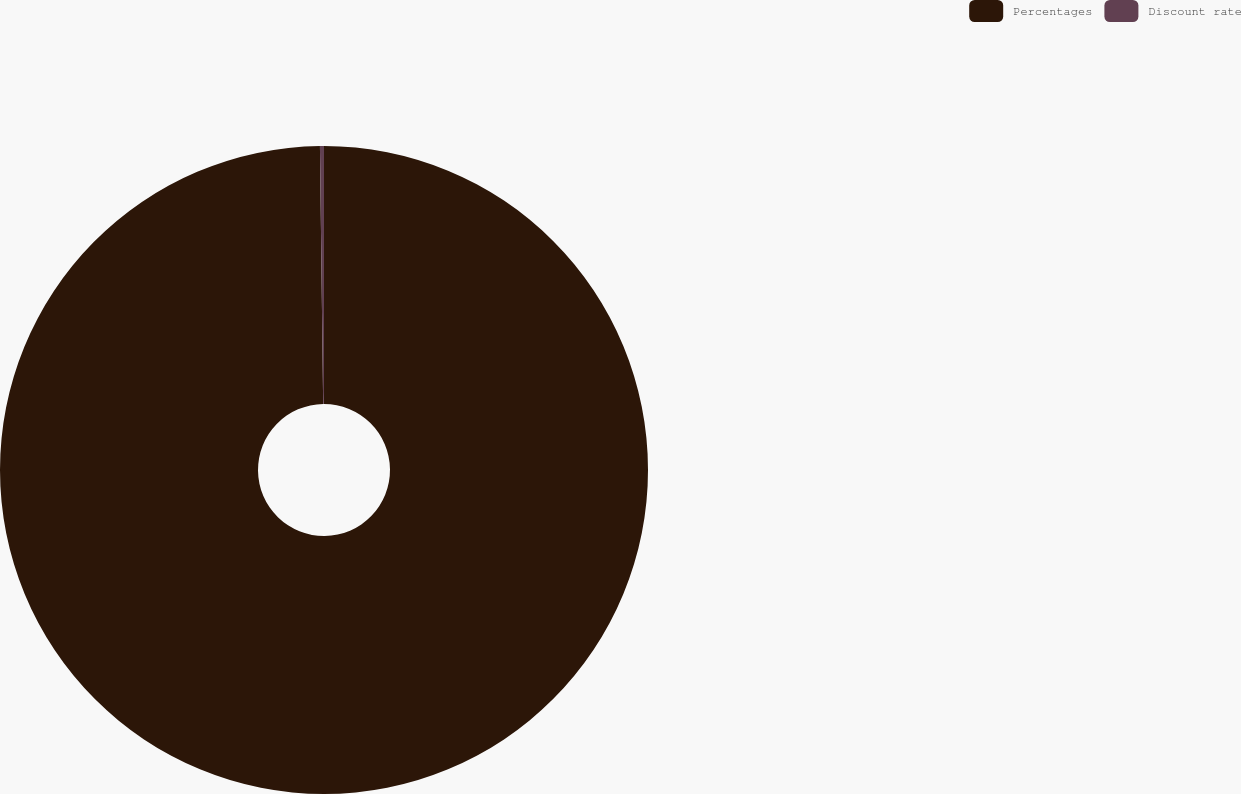Convert chart. <chart><loc_0><loc_0><loc_500><loc_500><pie_chart><fcel>Percentages<fcel>Discount rate<nl><fcel>99.8%<fcel>0.2%<nl></chart> 